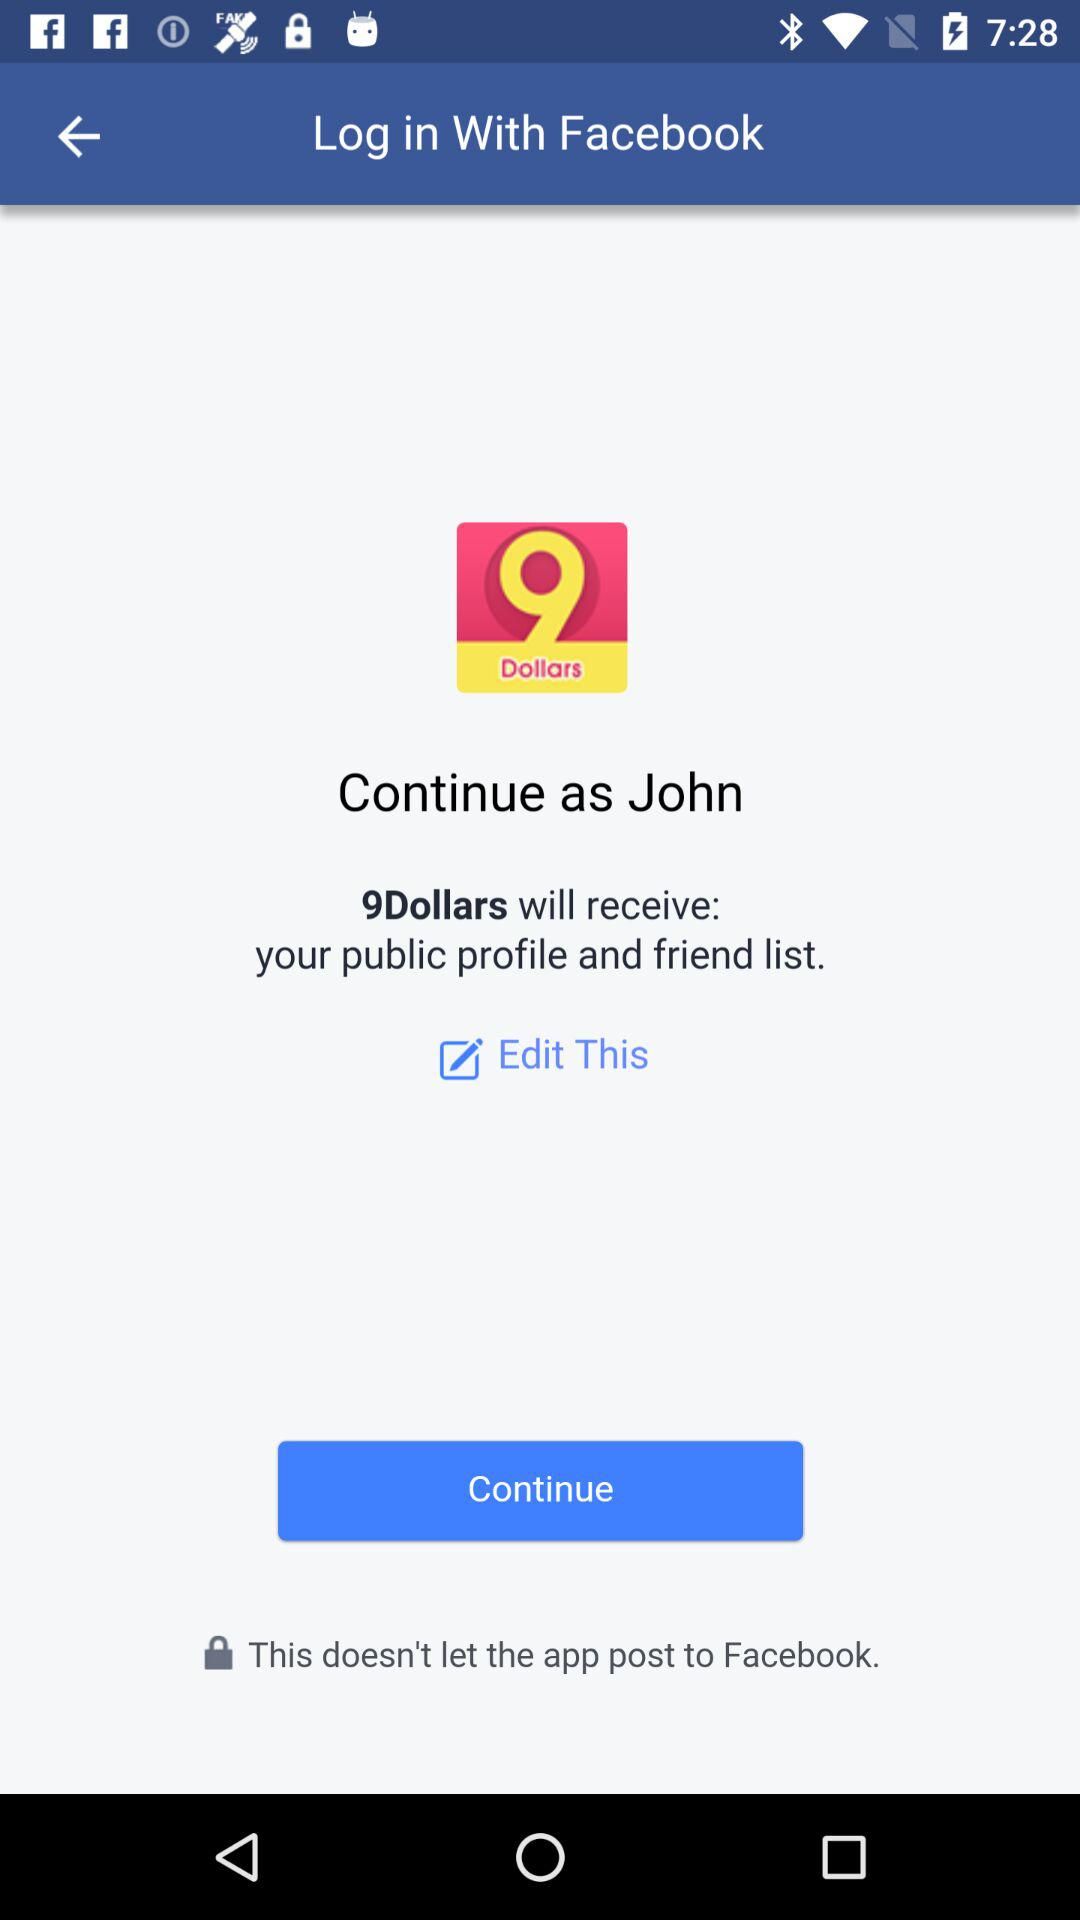What application can be used for logging in? The application that can be used for logging in is "Facebook". 